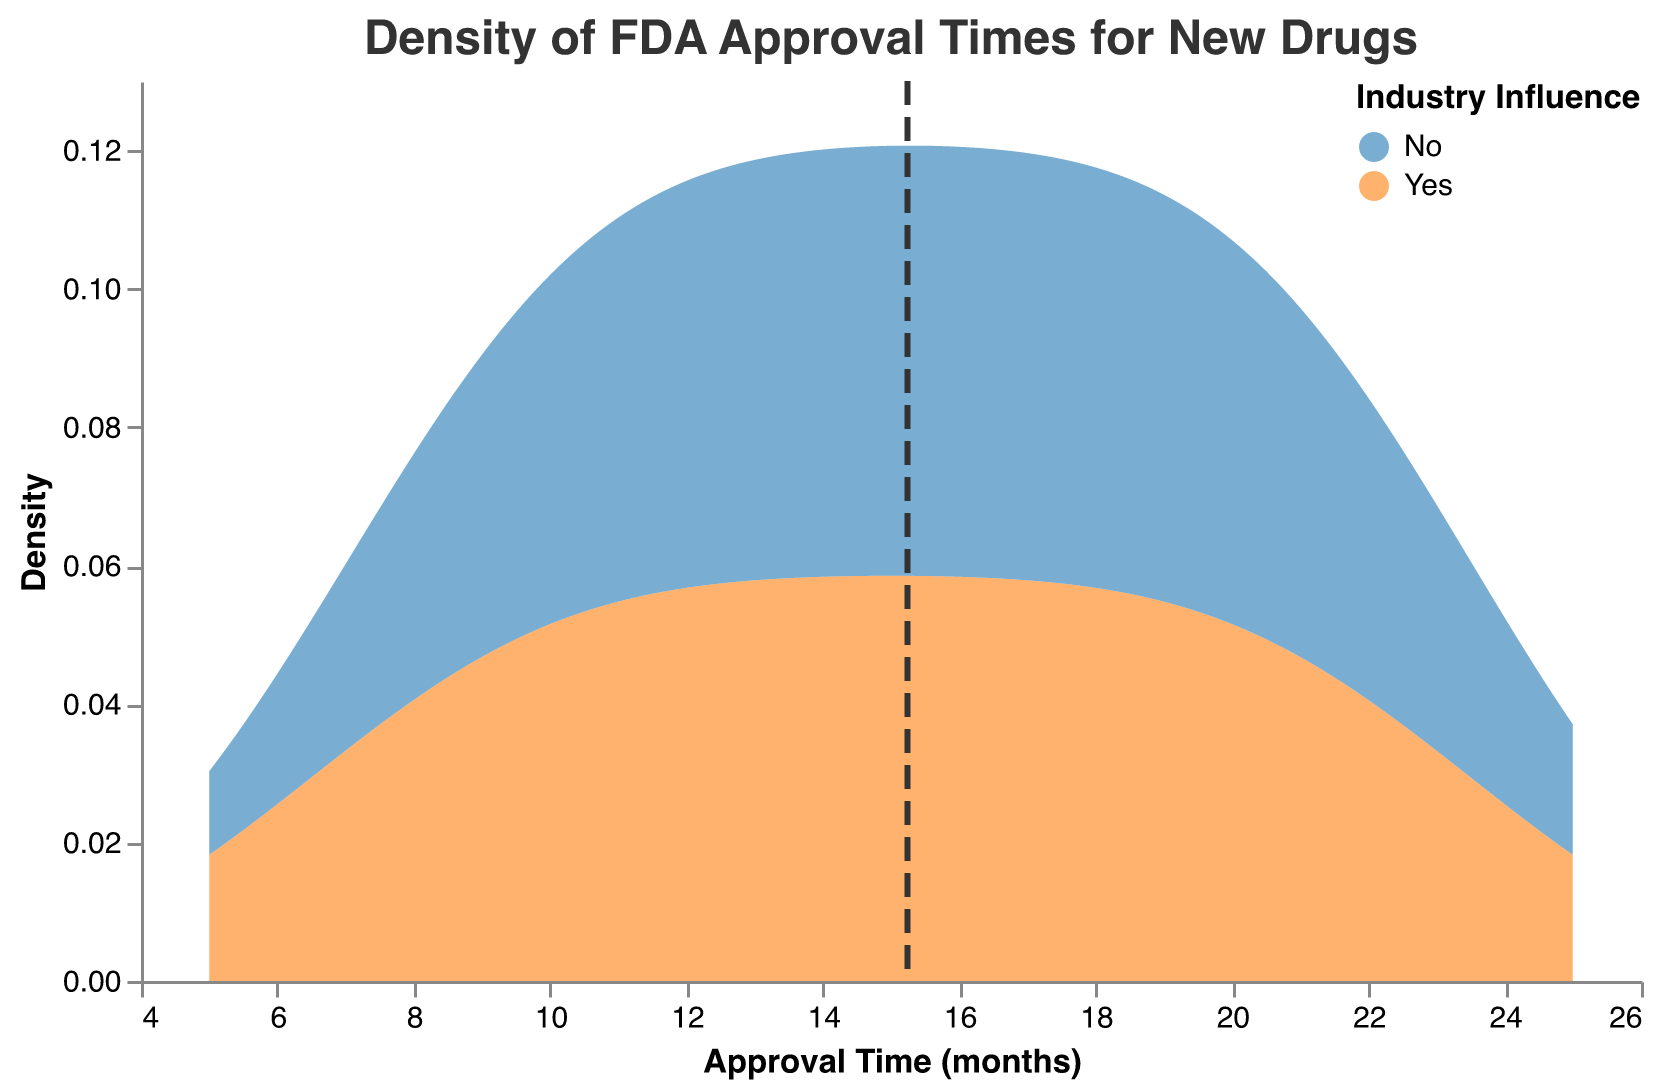What is the title of the plot? The title is usually located at the top of the plot, where we can see the name or description of the data that the plot represents. From the data provided, the plot title is "Density of FDA Approval Times for New Drugs."
Answer: Density of FDA Approval Times for New Drugs Which color represents drugs with industry influence? To identify which color represents "Yes" for industry influence, we can refer to the legend. The legend in the plot uses a blue color to denote "Yes."
Answer: Blue Which industry's influence has a higher density at 10 months of approval time? By examining the y-value (density) at the x-value (10 months), we can compare the height of the density curves for both colors. The density curve for the "Yes" industry influence is higher at 10 months.
Answer: Yes What is the minimum approval time shown in the plot? The x-axis represents approval times, and by looking at the lowest point of the x-axis range, we can see that the minimum approval time shown is 5 months.
Answer: 5 months Where is the mean approval time for all drugs approximately located on the plot? The mean approval time is indicated by a dashed vertical line. Using the plot's data, the mean approval time appears to be around 16 months.
Answer: Around 16 months Is there a noticeable difference in the peaks of the density plots for drugs with and without industry influence? Observing the shape and peak locations of the density plots, the peaks for both "Yes" and "No" industry influences appear at similar approval times, roughly around 10 to 15 months.
Answer: No noticeable difference Which group shows more variability in FDA approval times? Variability in approval times can be inferred from the width of the density curves. A wider curve indicates a broader spread of values. The "Yes" industry influence group shows wider variability compared to the "No" group.
Answer: Yes What is the range of approval times covered by the plot? The x-axis range indicates the extent of the approval times plotted, which covers from approximately 5 months to 25 months.
Answer: 5 to 25 months Which group has a higher density for approval times greater than 20 months? By looking at the density along the x-axis at values greater than 20 months, the "No" industry influence group shows a higher density.
Answer: No Is the mean approval time within the range of the FDA approval times for both groups? The mean approval time is marked on the plot and falls within the range of 5 to 25 months for both groups.
Answer: Yes 